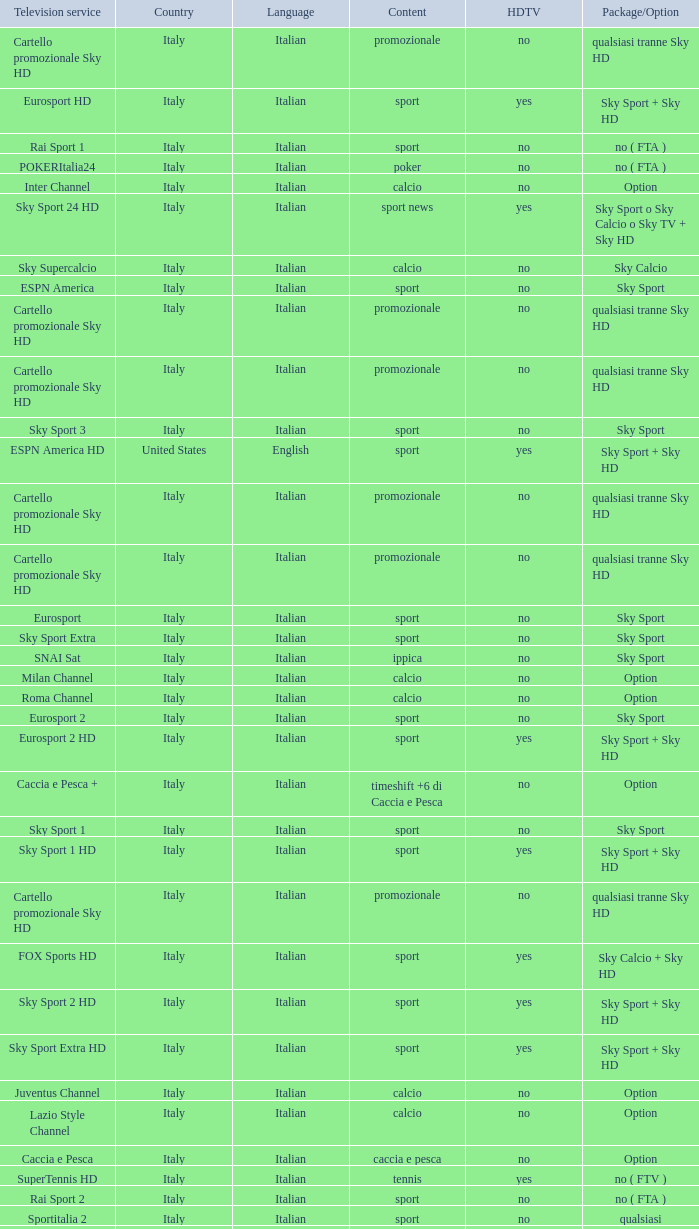What is Package/Option, when Content is Tennis? No ( ftv ). 